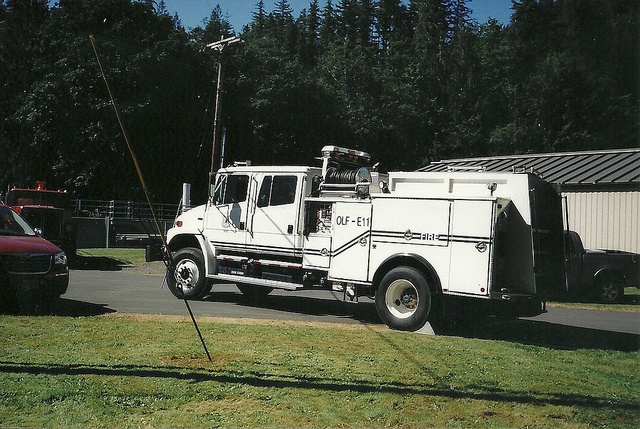Describe the objects in this image and their specific colors. I can see truck in navy, black, ivory, gray, and darkgray tones, car in navy, black, gray, maroon, and purple tones, truck in navy, black, gray, lightgray, and darkgray tones, and truck in navy, black, maroon, gray, and brown tones in this image. 